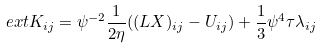Convert formula to latex. <formula><loc_0><loc_0><loc_500><loc_500>\ e x t K _ { i j } = \psi ^ { - 2 } \frac { 1 } { 2 \eta } ( ( L X ) _ { i j } - U _ { i j } ) + \frac { 1 } { 3 } \psi ^ { 4 } \tau \lambda _ { i j }</formula> 